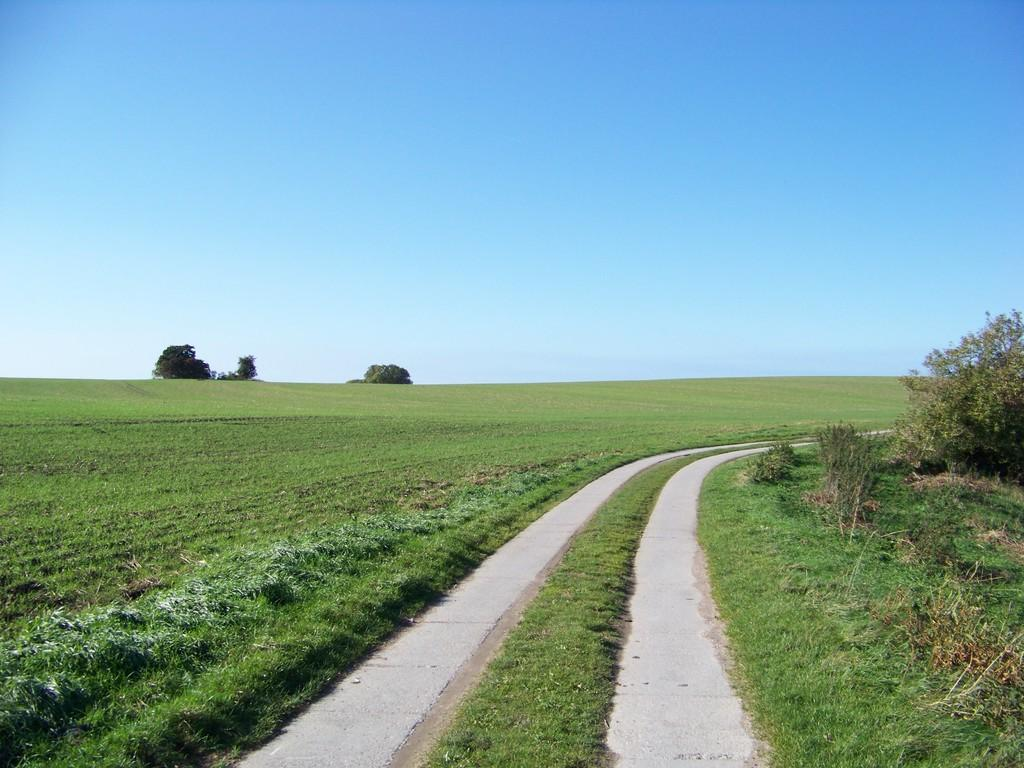What type of vegetation is present in the image? There is grass, plants, and trees in the image. What can be seen in the background of the image? The sky is visible in the background of the image. What type of jar is visible on the tree in the image? There is no jar present on any of the trees in the image. How many cards can be seen scattered on the grass in the image? There are no cards present in the image; it only features grass, plants, trees, and the sky. 